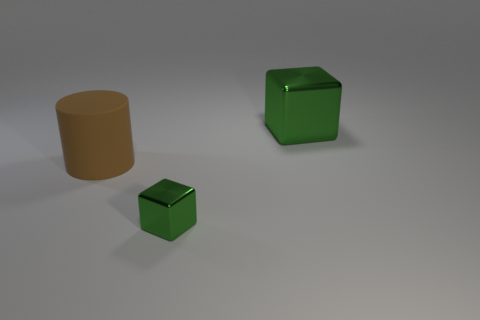There is a object that is both on the right side of the matte cylinder and behind the tiny green thing; what is it made of?
Your answer should be compact. Metal. There is a large thing that is the same shape as the tiny shiny thing; what is its color?
Your answer should be compact. Green. How big is the brown matte thing?
Your response must be concise. Large. There is a shiny object that is on the left side of the green shiny cube that is behind the big brown matte cylinder; what color is it?
Provide a short and direct response. Green. How many objects are to the left of the big block and right of the large matte object?
Provide a short and direct response. 1. Is the number of large matte cylinders greater than the number of large green matte blocks?
Make the answer very short. Yes. What is the tiny thing made of?
Make the answer very short. Metal. There is a green object behind the small shiny object; what number of green cubes are to the left of it?
Offer a very short reply. 1. Do the large metallic cube and the cube that is in front of the big green cube have the same color?
Your answer should be very brief. Yes. What is the color of the block that is the same size as the cylinder?
Your response must be concise. Green. 